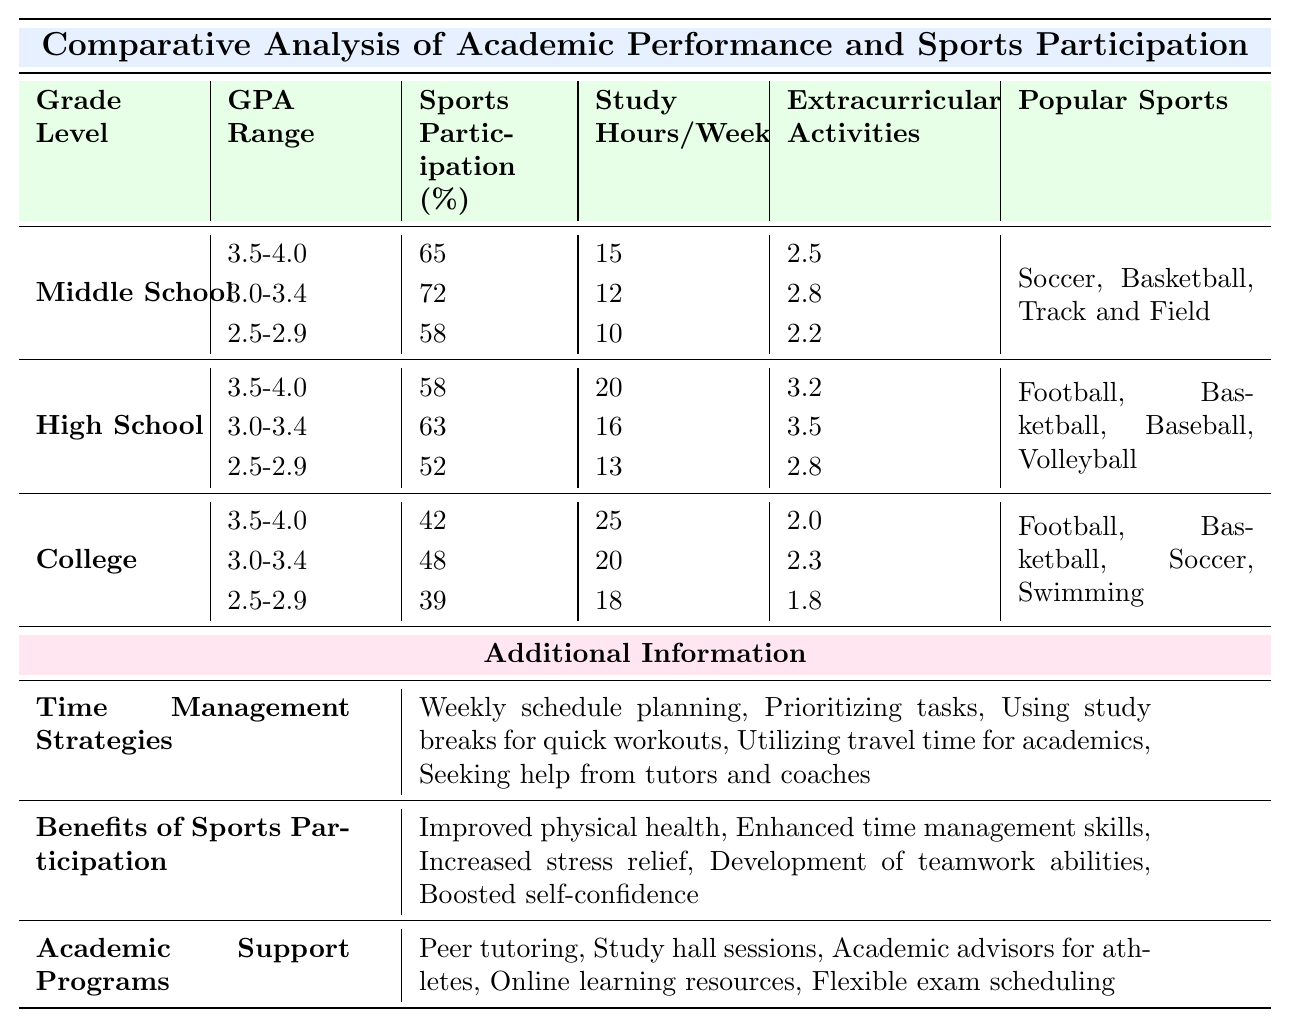What is the average sports participation percentage for Middle School students with a GPA range of 3.0-3.4? For Middle School students with a GPA range of 3.0-3.4, the sports participation is 72%.
Answer: 72% How many extracurricular activities do High School students with a GPA of 2.5-2.9 participate in compared to those with a GPA of 3.5-4.0? High School students with a GPA of 2.5-2.9 participate in 2.8 extracurricular activities, while those with a GPA of 3.5-4.0 participate in 3.2 activities. The difference is 3.2 - 2.8 = 0.4, meaning the higher GPA group has more activities.
Answer: 0.4 Is the average study hours per week for College students with a GPA of 3.0-3.4 higher than for Middle School students with a GPA of 3.5-4.0? College students with a GPA of 3.0-3.4 study for 20 hours per week, while Middle School students with a GPA of 3.5-4.0 study for 15 hours per week. Since 20 > 15, the College students study more.
Answer: Yes What is the total average training hours per week for all students across all grade levels? Middle School has an average of 8, High School has 12, and College has 20 training hours. Total average is (8 + 12 + 20) / 3 = 40 / 3 ≈ 13.33 hours.
Answer: 13.33 Is it true that College students with a GPA of 2.5-2.9 participate more in sports than High School students with the same GPA range? The sports participation for College students with a GPA of 2.5-2.9 is 39%, while for High School students with the same GPA range, it is 52%. Since 39 < 52, the statement is false.
Answer: No How does the average study hours per week of Middle School students compare to that of College students? Middle School students have an average of 15 hours (3.5-4.0), while College students with the same GPA have an average of 25. Since 25 > 15, College students study more on average.
Answer: College students study more What is the relationship between extracurricular activities and study hours per week for High School students with a GPA of 3.0-3.4? High School students with a GPA of 3.0-3.4 participate in 3.5 extracurricular activities and study for 16 hours a week. The positive correlation indicates they balance both well; more activities require good time management.
Answer: Positive correlation What is the average sports participation for all grade levels combined? Middle School sports participation is (65 + 72 + 58) / 3 = 65, High School is (58 + 63 + 52) / 3 = 57.67, and College is (42 + 48 + 39) / 3 = 43. Therefore, average participation is (65 + 57.67 + 43) / 3 = 55.22% approximately.
Answer: 55.22% Are the popular sports listed for College students the same as for Middle School students? College popular sports are Football, Basketball, Soccer, Swimming, while Middle School lists Soccer, Basketball, Track and Field. Since they differ, the answer is no.
Answer: No Which grade level has the highest average study hours per week and what is that average? College students with a GPA of 3.5-4.0 study for 25 hours per week on average, the highest compared to Middle (15 hours) and High School (20 hours).
Answer: College, 25 hours 